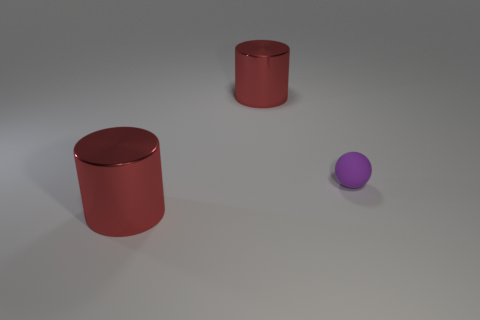Add 1 purple rubber spheres. How many objects exist? 4 Subtract all cylinders. How many objects are left? 1 Subtract all purple balls. Subtract all rubber objects. How many objects are left? 1 Add 1 large red metal cylinders. How many large red metal cylinders are left? 3 Add 1 blue metallic things. How many blue metallic things exist? 1 Subtract 0 yellow spheres. How many objects are left? 3 Subtract all gray spheres. Subtract all cyan cubes. How many spheres are left? 1 